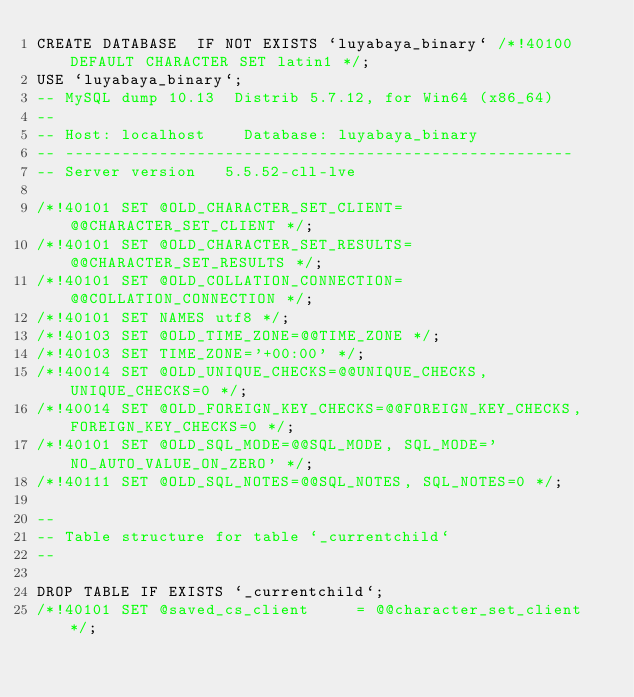Convert code to text. <code><loc_0><loc_0><loc_500><loc_500><_SQL_>CREATE DATABASE  IF NOT EXISTS `luyabaya_binary` /*!40100 DEFAULT CHARACTER SET latin1 */;
USE `luyabaya_binary`;
-- MySQL dump 10.13  Distrib 5.7.12, for Win64 (x86_64)
--
-- Host: localhost    Database: luyabaya_binary
-- ------------------------------------------------------
-- Server version	5.5.52-cll-lve

/*!40101 SET @OLD_CHARACTER_SET_CLIENT=@@CHARACTER_SET_CLIENT */;
/*!40101 SET @OLD_CHARACTER_SET_RESULTS=@@CHARACTER_SET_RESULTS */;
/*!40101 SET @OLD_COLLATION_CONNECTION=@@COLLATION_CONNECTION */;
/*!40101 SET NAMES utf8 */;
/*!40103 SET @OLD_TIME_ZONE=@@TIME_ZONE */;
/*!40103 SET TIME_ZONE='+00:00' */;
/*!40014 SET @OLD_UNIQUE_CHECKS=@@UNIQUE_CHECKS, UNIQUE_CHECKS=0 */;
/*!40014 SET @OLD_FOREIGN_KEY_CHECKS=@@FOREIGN_KEY_CHECKS, FOREIGN_KEY_CHECKS=0 */;
/*!40101 SET @OLD_SQL_MODE=@@SQL_MODE, SQL_MODE='NO_AUTO_VALUE_ON_ZERO' */;
/*!40111 SET @OLD_SQL_NOTES=@@SQL_NOTES, SQL_NOTES=0 */;

--
-- Table structure for table `_currentchild`
--

DROP TABLE IF EXISTS `_currentchild`;
/*!40101 SET @saved_cs_client     = @@character_set_client */;</code> 